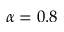Convert formula to latex. <formula><loc_0><loc_0><loc_500><loc_500>\alpha = 0 . 8</formula> 